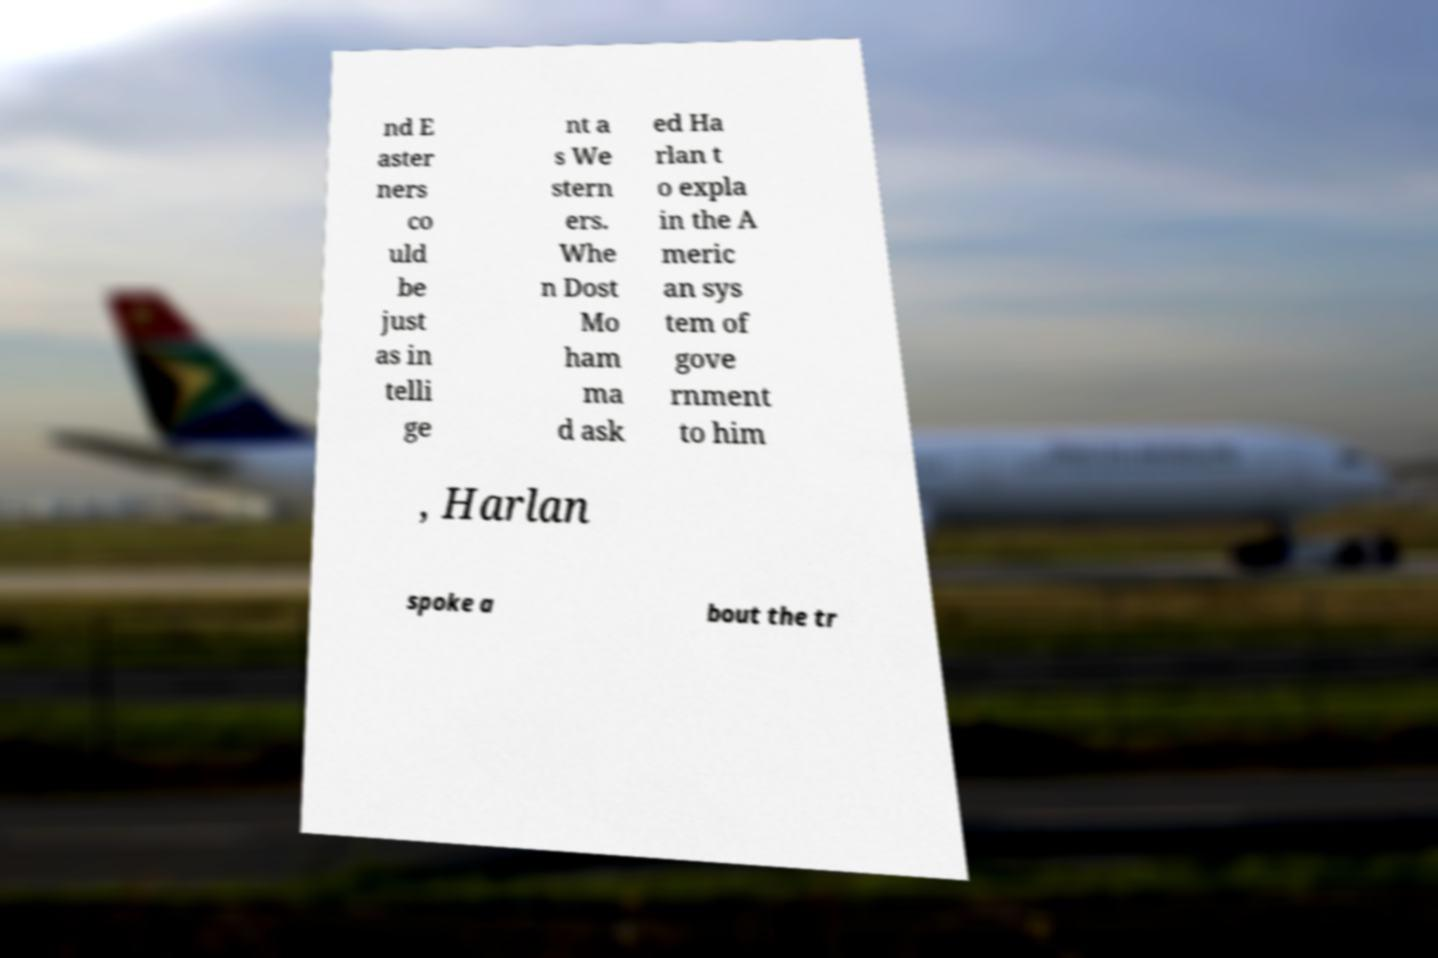Can you accurately transcribe the text from the provided image for me? nd E aster ners co uld be just as in telli ge nt a s We stern ers. Whe n Dost Mo ham ma d ask ed Ha rlan t o expla in the A meric an sys tem of gove rnment to him , Harlan spoke a bout the tr 